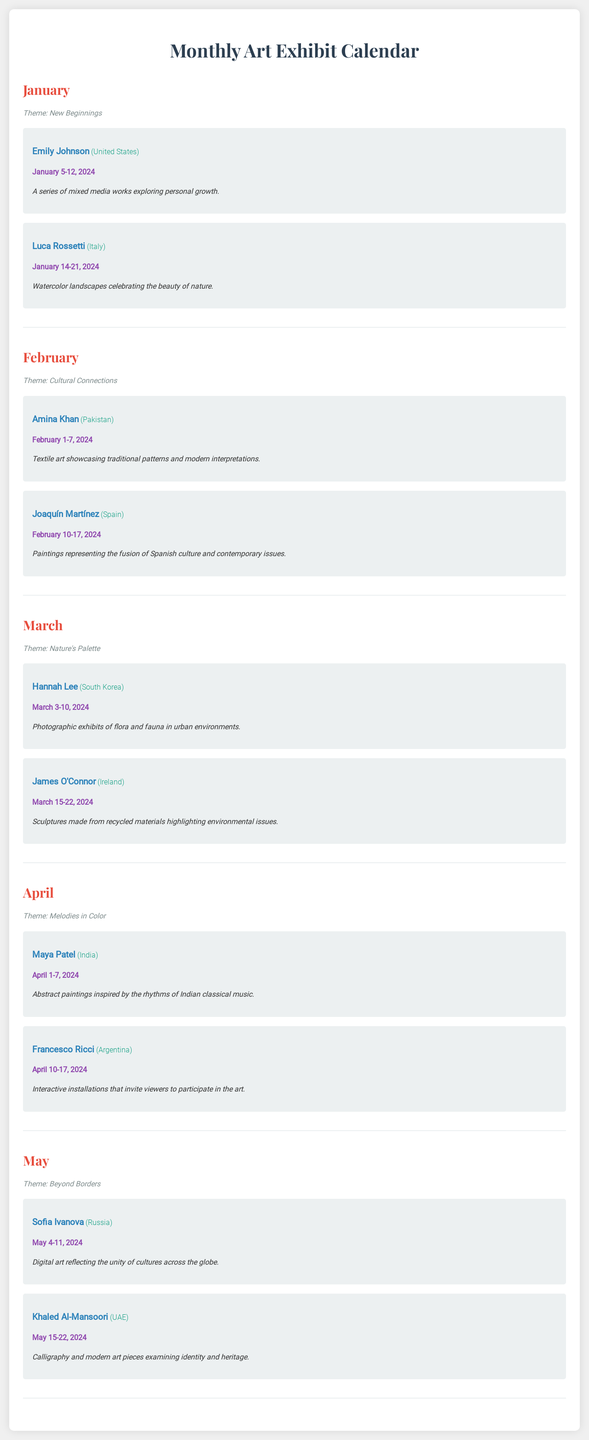What is the theme for January? The theme for January is specified as "New Beginnings."
Answer: New Beginnings Who is the artist from Italy in January? The document lists Luca Rossetti as the artist from Italy for the January exhibit.
Answer: Luca Rossetti When does Amina Khan's exhibit take place? Amina Khan's exhibit dates are mentioned in the document as February 1-7, 2024.
Answer: February 1-7, 2024 What medium does James O'Connor use for his sculptures? The document states that James O'Connor makes sculptures from recycled materials, highlighting environmental issues.
Answer: Recycled materials Which month features the theme "Beyond Borders"? The theme "Beyond Borders" is mentioned for May in the document.
Answer: May How many artists are exhibiting in April? The document indicates that there are two artists exhibiting in April.
Answer: Two What type of art does Sofia Ivanova create? The document describes Sofia Ivanova's art as digital art reflecting the unity of cultures across the globe.
Answer: Digital art Who has their work displayed from March 15-22, 2024? The artist displaying work from March 15-22, 2024, is James O'Connor.
Answer: James O'Connor 